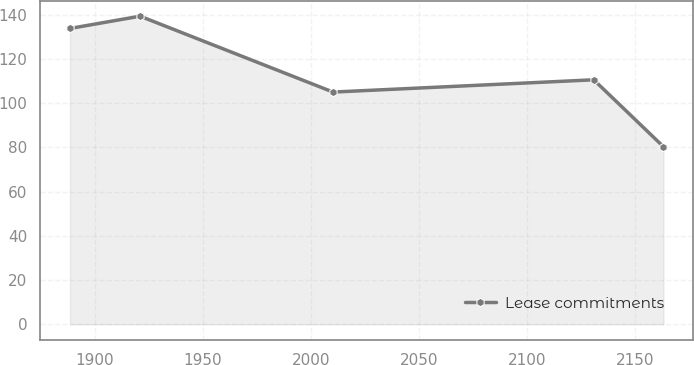<chart> <loc_0><loc_0><loc_500><loc_500><line_chart><ecel><fcel>Lease commitments<nl><fcel>1888.61<fcel>133.77<nl><fcel>1921<fcel>139.32<nl><fcel>2010.23<fcel>105<nl><fcel>2130.76<fcel>110.55<nl><fcel>2162.99<fcel>80.29<nl></chart> 